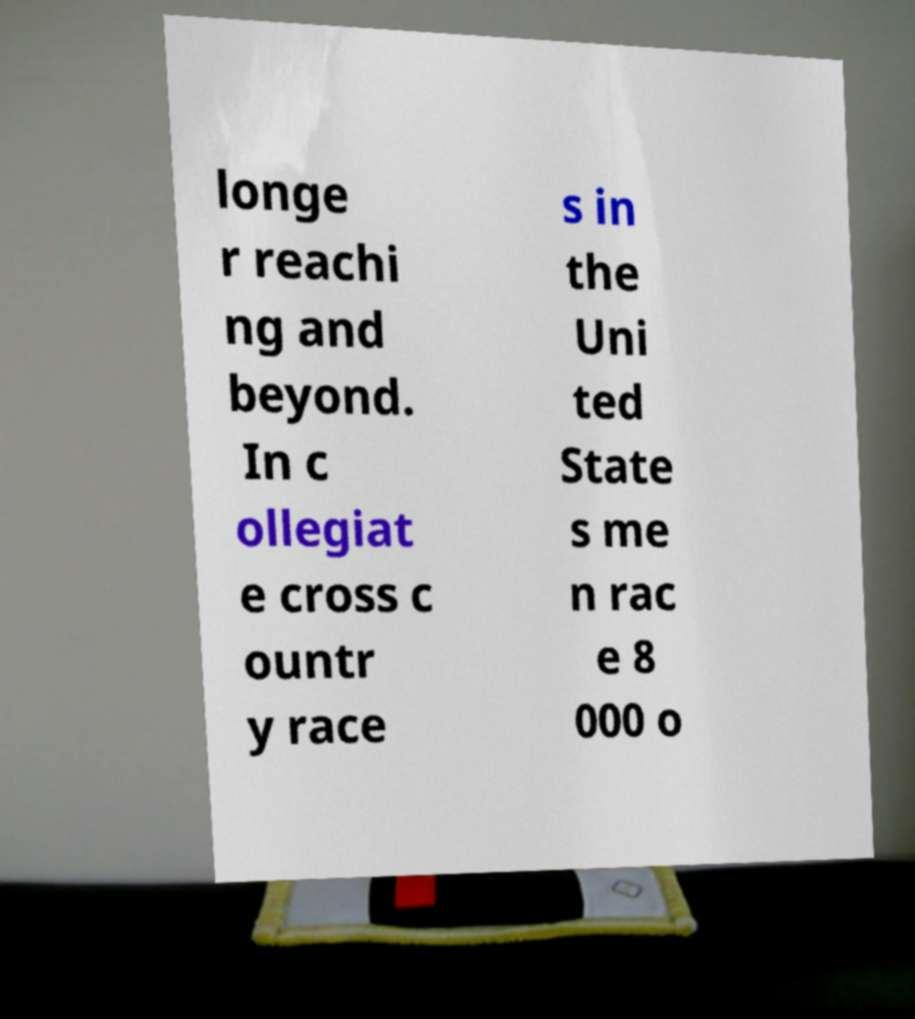Could you assist in decoding the text presented in this image and type it out clearly? longe r reachi ng and beyond. In c ollegiat e cross c ountr y race s in the Uni ted State s me n rac e 8 000 o 